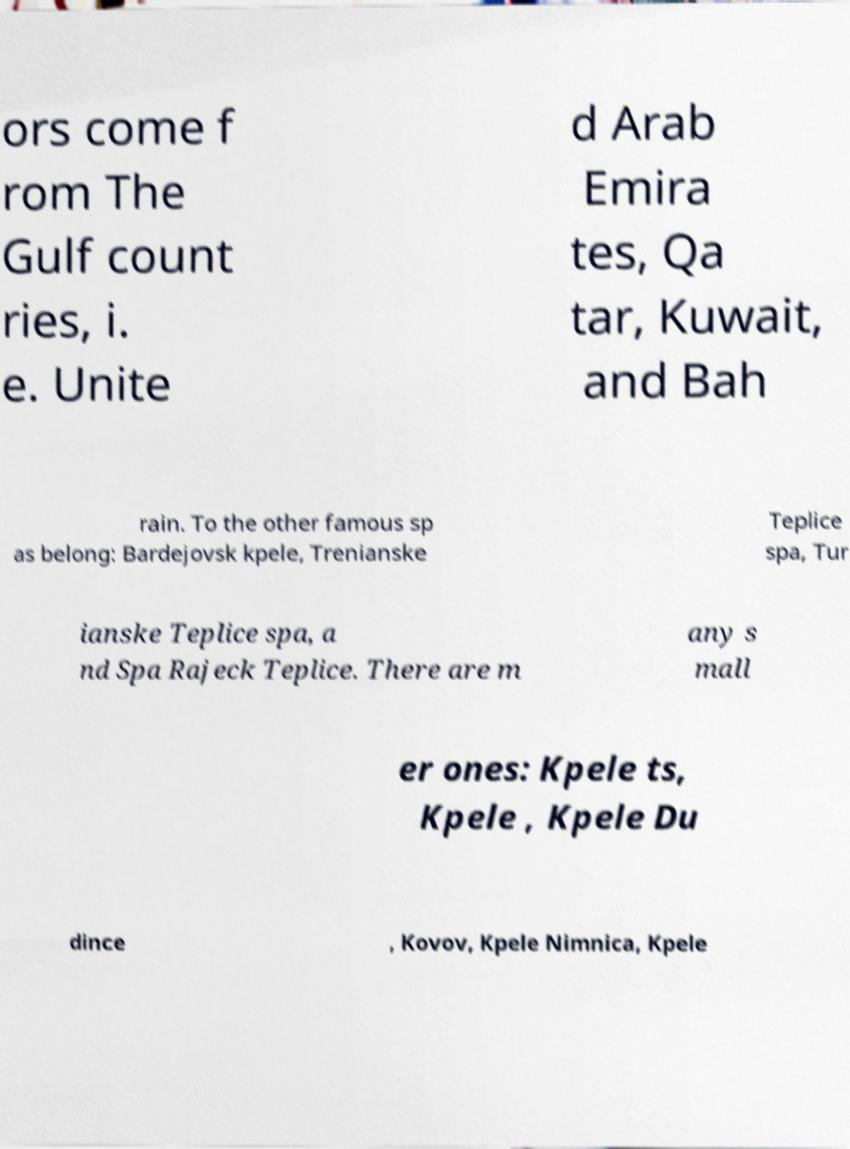Could you extract and type out the text from this image? ors come f rom The Gulf count ries, i. e. Unite d Arab Emira tes, Qa tar, Kuwait, and Bah rain. To the other famous sp as belong: Bardejovsk kpele, Trenianske Teplice spa, Tur ianske Teplice spa, a nd Spa Rajeck Teplice. There are m any s mall er ones: Kpele ts, Kpele , Kpele Du dince , Kovov, Kpele Nimnica, Kpele 